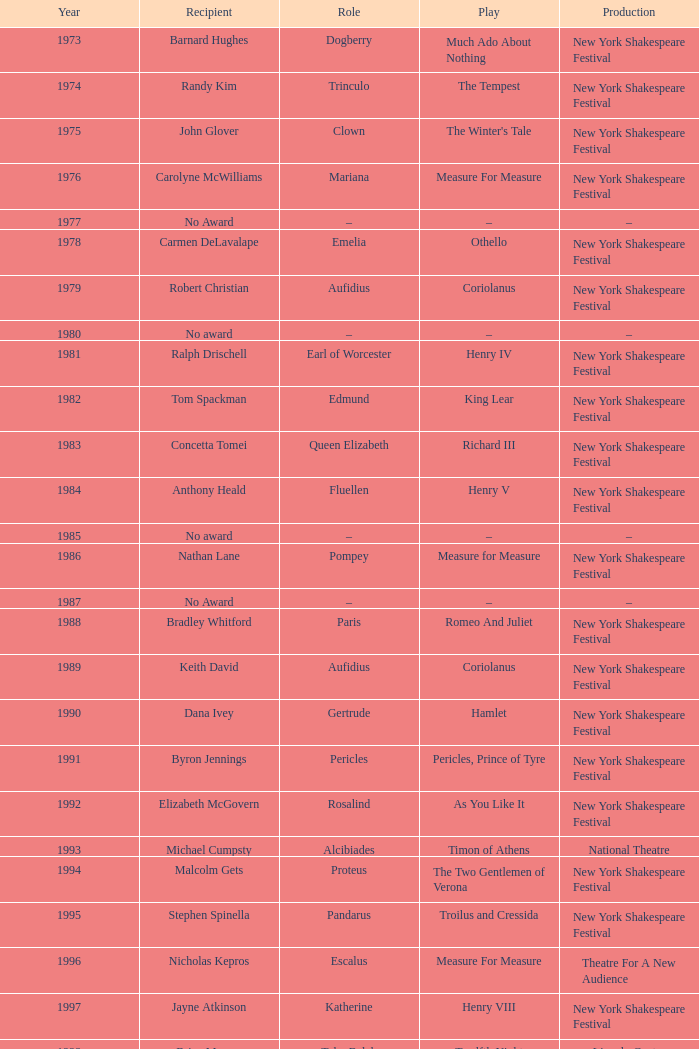Name the average year for much ado about nothing and recipient of ray virta 2002.0. 